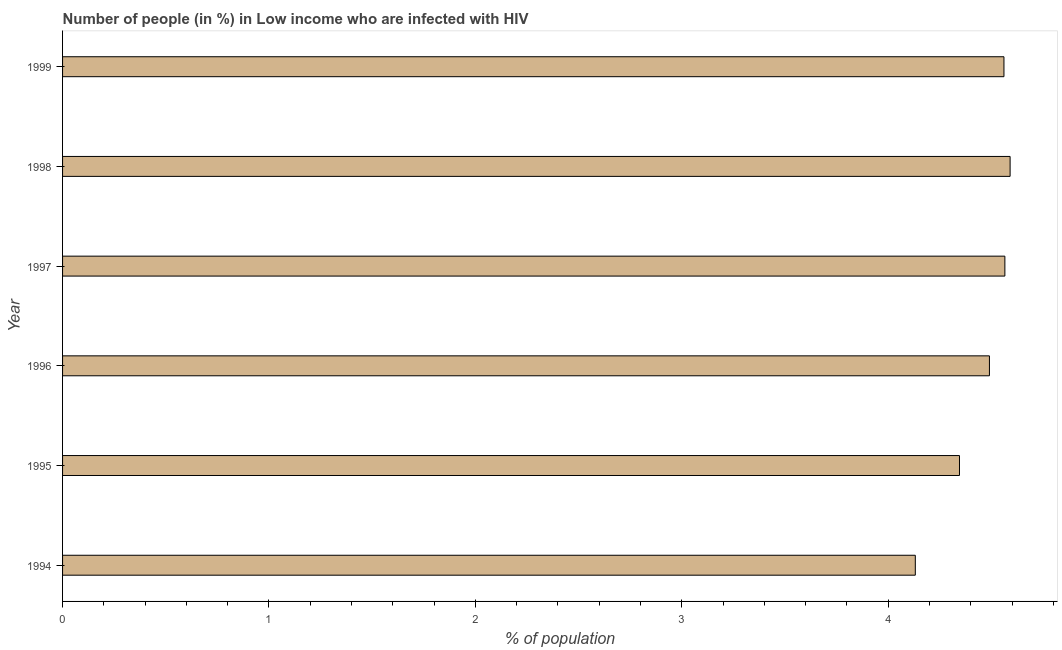Does the graph contain grids?
Your response must be concise. No. What is the title of the graph?
Your answer should be very brief. Number of people (in %) in Low income who are infected with HIV. What is the label or title of the X-axis?
Ensure brevity in your answer.  % of population. What is the label or title of the Y-axis?
Make the answer very short. Year. What is the number of people infected with hiv in 1999?
Keep it short and to the point. 4.56. Across all years, what is the maximum number of people infected with hiv?
Provide a succinct answer. 4.59. Across all years, what is the minimum number of people infected with hiv?
Your answer should be compact. 4.13. What is the sum of the number of people infected with hiv?
Ensure brevity in your answer.  26.69. What is the difference between the number of people infected with hiv in 1997 and 1999?
Your answer should be very brief. 0. What is the average number of people infected with hiv per year?
Keep it short and to the point. 4.45. What is the median number of people infected with hiv?
Your answer should be compact. 4.53. In how many years, is the number of people infected with hiv greater than 4 %?
Provide a succinct answer. 6. Is the number of people infected with hiv in 1995 less than that in 1998?
Keep it short and to the point. Yes. What is the difference between the highest and the second highest number of people infected with hiv?
Make the answer very short. 0.03. Is the sum of the number of people infected with hiv in 1995 and 1999 greater than the maximum number of people infected with hiv across all years?
Your answer should be very brief. Yes. What is the difference between the highest and the lowest number of people infected with hiv?
Your answer should be very brief. 0.46. In how many years, is the number of people infected with hiv greater than the average number of people infected with hiv taken over all years?
Make the answer very short. 4. Are the values on the major ticks of X-axis written in scientific E-notation?
Your answer should be very brief. No. What is the % of population in 1994?
Your answer should be very brief. 4.13. What is the % of population of 1995?
Your answer should be very brief. 4.35. What is the % of population in 1996?
Ensure brevity in your answer.  4.49. What is the % of population in 1997?
Offer a terse response. 4.57. What is the % of population in 1998?
Provide a succinct answer. 4.59. What is the % of population of 1999?
Offer a very short reply. 4.56. What is the difference between the % of population in 1994 and 1995?
Your answer should be compact. -0.21. What is the difference between the % of population in 1994 and 1996?
Offer a very short reply. -0.36. What is the difference between the % of population in 1994 and 1997?
Your response must be concise. -0.43. What is the difference between the % of population in 1994 and 1998?
Keep it short and to the point. -0.46. What is the difference between the % of population in 1994 and 1999?
Provide a short and direct response. -0.43. What is the difference between the % of population in 1995 and 1996?
Give a very brief answer. -0.15. What is the difference between the % of population in 1995 and 1997?
Your answer should be very brief. -0.22. What is the difference between the % of population in 1995 and 1998?
Keep it short and to the point. -0.25. What is the difference between the % of population in 1995 and 1999?
Ensure brevity in your answer.  -0.22. What is the difference between the % of population in 1996 and 1997?
Make the answer very short. -0.07. What is the difference between the % of population in 1996 and 1998?
Offer a very short reply. -0.1. What is the difference between the % of population in 1996 and 1999?
Make the answer very short. -0.07. What is the difference between the % of population in 1997 and 1998?
Your response must be concise. -0.03. What is the difference between the % of population in 1997 and 1999?
Your answer should be very brief. 0. What is the difference between the % of population in 1998 and 1999?
Your answer should be compact. 0.03. What is the ratio of the % of population in 1994 to that in 1995?
Make the answer very short. 0.95. What is the ratio of the % of population in 1994 to that in 1997?
Offer a very short reply. 0.91. What is the ratio of the % of population in 1994 to that in 1998?
Provide a succinct answer. 0.9. What is the ratio of the % of population in 1994 to that in 1999?
Your response must be concise. 0.91. What is the ratio of the % of population in 1995 to that in 1998?
Give a very brief answer. 0.95. What is the ratio of the % of population in 1995 to that in 1999?
Offer a very short reply. 0.95. What is the ratio of the % of population in 1996 to that in 1999?
Your answer should be very brief. 0.98. What is the ratio of the % of population in 1997 to that in 1998?
Provide a short and direct response. 0.99. 